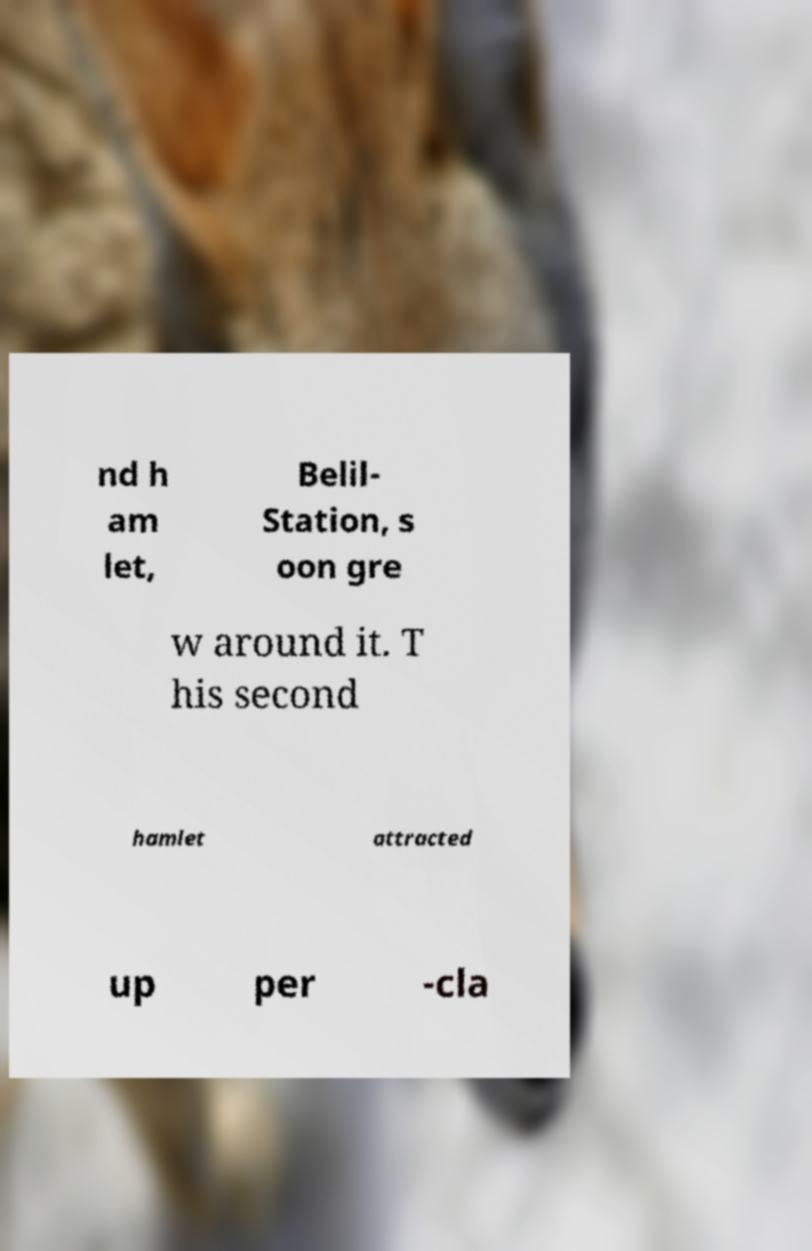Please identify and transcribe the text found in this image. nd h am let, Belil- Station, s oon gre w around it. T his second hamlet attracted up per -cla 